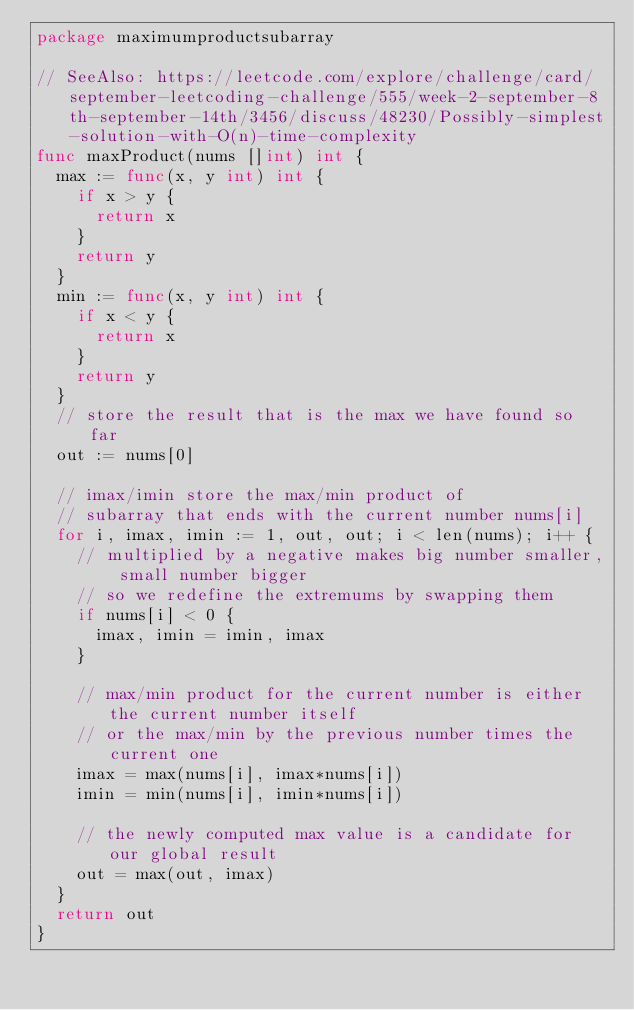Convert code to text. <code><loc_0><loc_0><loc_500><loc_500><_Go_>package maximumproductsubarray

// SeeAlso: https://leetcode.com/explore/challenge/card/september-leetcoding-challenge/555/week-2-september-8th-september-14th/3456/discuss/48230/Possibly-simplest-solution-with-O(n)-time-complexity
func maxProduct(nums []int) int {
	max := func(x, y int) int {
		if x > y {
			return x
		}
		return y
	}
	min := func(x, y int) int {
		if x < y {
			return x
		}
		return y
	}
	// store the result that is the max we have found so far
	out := nums[0]

	// imax/imin store the max/min product of
	// subarray that ends with the current number nums[i]
	for i, imax, imin := 1, out, out; i < len(nums); i++ {
		// multiplied by a negative makes big number smaller, small number bigger
		// so we redefine the extremums by swapping them
		if nums[i] < 0 {
			imax, imin = imin, imax
		}

		// max/min product for the current number is either the current number itself
		// or the max/min by the previous number times the current one
		imax = max(nums[i], imax*nums[i])
		imin = min(nums[i], imin*nums[i])

		// the newly computed max value is a candidate for our global result
		out = max(out, imax)
	}
	return out
}
</code> 